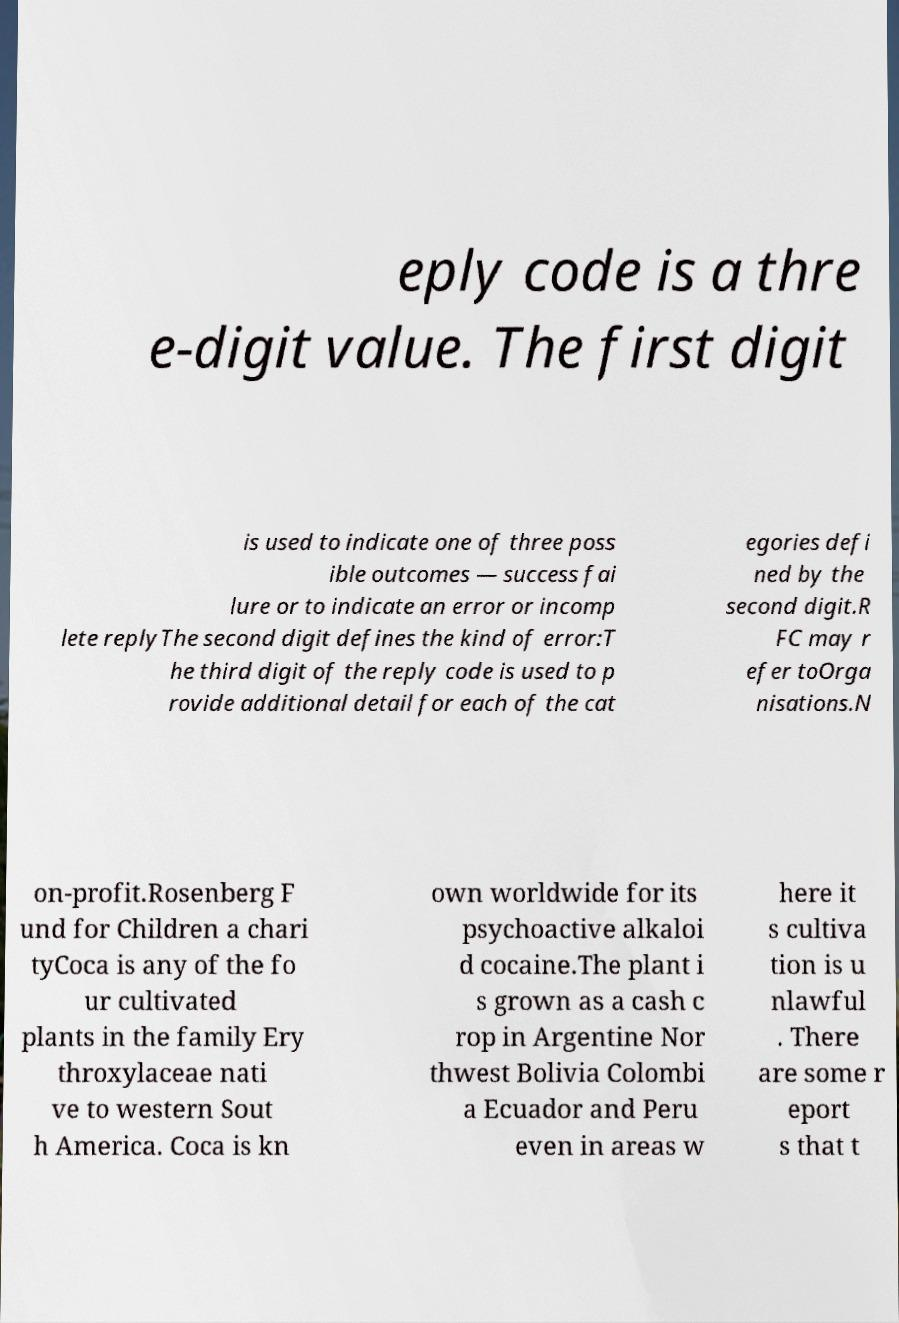Please identify and transcribe the text found in this image. eply code is a thre e-digit value. The first digit is used to indicate one of three poss ible outcomes — success fai lure or to indicate an error or incomp lete replyThe second digit defines the kind of error:T he third digit of the reply code is used to p rovide additional detail for each of the cat egories defi ned by the second digit.R FC may r efer toOrga nisations.N on-profit.Rosenberg F und for Children a chari tyCoca is any of the fo ur cultivated plants in the family Ery throxylaceae nati ve to western Sout h America. Coca is kn own worldwide for its psychoactive alkaloi d cocaine.The plant i s grown as a cash c rop in Argentine Nor thwest Bolivia Colombi a Ecuador and Peru even in areas w here it s cultiva tion is u nlawful . There are some r eport s that t 